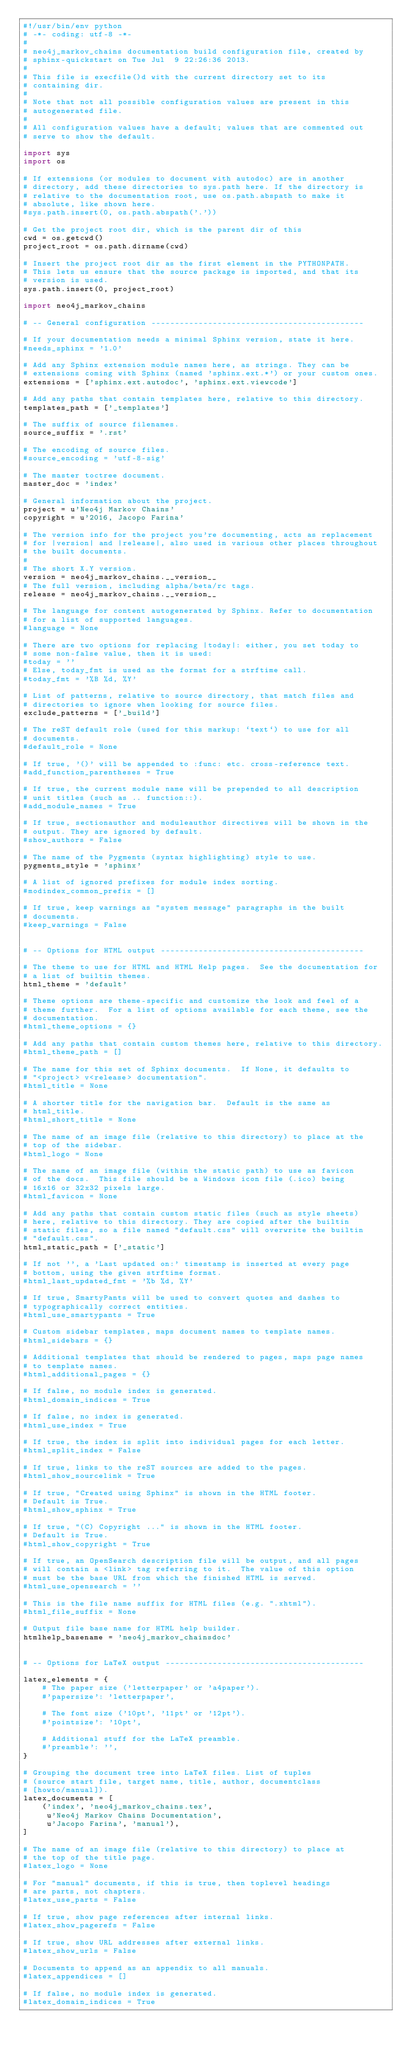Convert code to text. <code><loc_0><loc_0><loc_500><loc_500><_Python_>#!/usr/bin/env python
# -*- coding: utf-8 -*-
#
# neo4j_markov_chains documentation build configuration file, created by
# sphinx-quickstart on Tue Jul  9 22:26:36 2013.
#
# This file is execfile()d with the current directory set to its
# containing dir.
#
# Note that not all possible configuration values are present in this
# autogenerated file.
#
# All configuration values have a default; values that are commented out
# serve to show the default.

import sys
import os

# If extensions (or modules to document with autodoc) are in another
# directory, add these directories to sys.path here. If the directory is
# relative to the documentation root, use os.path.abspath to make it
# absolute, like shown here.
#sys.path.insert(0, os.path.abspath('.'))

# Get the project root dir, which is the parent dir of this
cwd = os.getcwd()
project_root = os.path.dirname(cwd)

# Insert the project root dir as the first element in the PYTHONPATH.
# This lets us ensure that the source package is imported, and that its
# version is used.
sys.path.insert(0, project_root)

import neo4j_markov_chains

# -- General configuration ---------------------------------------------

# If your documentation needs a minimal Sphinx version, state it here.
#needs_sphinx = '1.0'

# Add any Sphinx extension module names here, as strings. They can be
# extensions coming with Sphinx (named 'sphinx.ext.*') or your custom ones.
extensions = ['sphinx.ext.autodoc', 'sphinx.ext.viewcode']

# Add any paths that contain templates here, relative to this directory.
templates_path = ['_templates']

# The suffix of source filenames.
source_suffix = '.rst'

# The encoding of source files.
#source_encoding = 'utf-8-sig'

# The master toctree document.
master_doc = 'index'

# General information about the project.
project = u'Neo4j Markov Chains'
copyright = u'2016, Jacopo Farina'

# The version info for the project you're documenting, acts as replacement
# for |version| and |release|, also used in various other places throughout
# the built documents.
#
# The short X.Y version.
version = neo4j_markov_chains.__version__
# The full version, including alpha/beta/rc tags.
release = neo4j_markov_chains.__version__

# The language for content autogenerated by Sphinx. Refer to documentation
# for a list of supported languages.
#language = None

# There are two options for replacing |today|: either, you set today to
# some non-false value, then it is used:
#today = ''
# Else, today_fmt is used as the format for a strftime call.
#today_fmt = '%B %d, %Y'

# List of patterns, relative to source directory, that match files and
# directories to ignore when looking for source files.
exclude_patterns = ['_build']

# The reST default role (used for this markup: `text`) to use for all
# documents.
#default_role = None

# If true, '()' will be appended to :func: etc. cross-reference text.
#add_function_parentheses = True

# If true, the current module name will be prepended to all description
# unit titles (such as .. function::).
#add_module_names = True

# If true, sectionauthor and moduleauthor directives will be shown in the
# output. They are ignored by default.
#show_authors = False

# The name of the Pygments (syntax highlighting) style to use.
pygments_style = 'sphinx'

# A list of ignored prefixes for module index sorting.
#modindex_common_prefix = []

# If true, keep warnings as "system message" paragraphs in the built
# documents.
#keep_warnings = False


# -- Options for HTML output -------------------------------------------

# The theme to use for HTML and HTML Help pages.  See the documentation for
# a list of builtin themes.
html_theme = 'default'

# Theme options are theme-specific and customize the look and feel of a
# theme further.  For a list of options available for each theme, see the
# documentation.
#html_theme_options = {}

# Add any paths that contain custom themes here, relative to this directory.
#html_theme_path = []

# The name for this set of Sphinx documents.  If None, it defaults to
# "<project> v<release> documentation".
#html_title = None

# A shorter title for the navigation bar.  Default is the same as
# html_title.
#html_short_title = None

# The name of an image file (relative to this directory) to place at the
# top of the sidebar.
#html_logo = None

# The name of an image file (within the static path) to use as favicon
# of the docs.  This file should be a Windows icon file (.ico) being
# 16x16 or 32x32 pixels large.
#html_favicon = None

# Add any paths that contain custom static files (such as style sheets)
# here, relative to this directory. They are copied after the builtin
# static files, so a file named "default.css" will overwrite the builtin
# "default.css".
html_static_path = ['_static']

# If not '', a 'Last updated on:' timestamp is inserted at every page
# bottom, using the given strftime format.
#html_last_updated_fmt = '%b %d, %Y'

# If true, SmartyPants will be used to convert quotes and dashes to
# typographically correct entities.
#html_use_smartypants = True

# Custom sidebar templates, maps document names to template names.
#html_sidebars = {}

# Additional templates that should be rendered to pages, maps page names
# to template names.
#html_additional_pages = {}

# If false, no module index is generated.
#html_domain_indices = True

# If false, no index is generated.
#html_use_index = True

# If true, the index is split into individual pages for each letter.
#html_split_index = False

# If true, links to the reST sources are added to the pages.
#html_show_sourcelink = True

# If true, "Created using Sphinx" is shown in the HTML footer.
# Default is True.
#html_show_sphinx = True

# If true, "(C) Copyright ..." is shown in the HTML footer.
# Default is True.
#html_show_copyright = True

# If true, an OpenSearch description file will be output, and all pages
# will contain a <link> tag referring to it.  The value of this option
# must be the base URL from which the finished HTML is served.
#html_use_opensearch = ''

# This is the file name suffix for HTML files (e.g. ".xhtml").
#html_file_suffix = None

# Output file base name for HTML help builder.
htmlhelp_basename = 'neo4j_markov_chainsdoc'


# -- Options for LaTeX output ------------------------------------------

latex_elements = {
    # The paper size ('letterpaper' or 'a4paper').
    #'papersize': 'letterpaper',

    # The font size ('10pt', '11pt' or '12pt').
    #'pointsize': '10pt',

    # Additional stuff for the LaTeX preamble.
    #'preamble': '',
}

# Grouping the document tree into LaTeX files. List of tuples
# (source start file, target name, title, author, documentclass
# [howto/manual]).
latex_documents = [
    ('index', 'neo4j_markov_chains.tex',
     u'Neo4j Markov Chains Documentation',
     u'Jacopo Farina', 'manual'),
]

# The name of an image file (relative to this directory) to place at
# the top of the title page.
#latex_logo = None

# For "manual" documents, if this is true, then toplevel headings
# are parts, not chapters.
#latex_use_parts = False

# If true, show page references after internal links.
#latex_show_pagerefs = False

# If true, show URL addresses after external links.
#latex_show_urls = False

# Documents to append as an appendix to all manuals.
#latex_appendices = []

# If false, no module index is generated.
#latex_domain_indices = True

</code> 